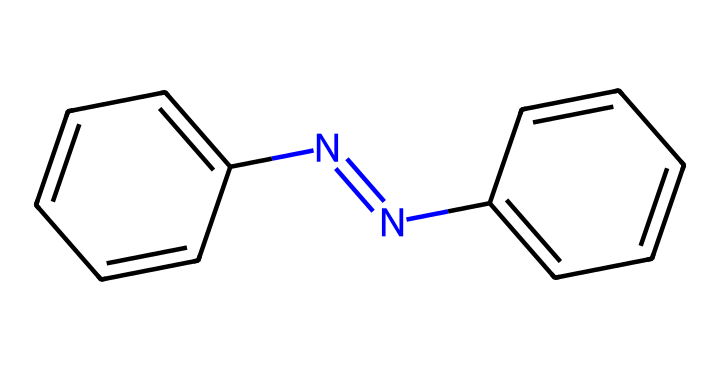What is the name of this chemical? The chemical structure represents azobenzene, which is characterized by the azo group (N=N) linking two phenyl rings.
Answer: azobenzene How many nitrogen atoms are present in this molecule? In the provided SMILES representation, there are two nitrogen atoms connected by a double bond (N=N).
Answer: two What is the overall molecular symmetry of azobenzene? Azobenzene exhibits planar molecular symmetry due to the arrangement of the two phenyl rings around the central azo group.
Answer: planar Which functional group is responsible for the photoswitchable properties of this molecule? The azo group (N=N) is responsible for the photoswitchable properties, allowing azobenzene to change its configuration upon light exposure.
Answer: azo group What is the effect of light on the configuration of azobenzene? Light causes azobenzene to undergo isomerization, specifically switching between the trans and cis configurations, changing its physical properties.
Answer: isomerization How many phenyl rings are in azobenzene? There are two phenyl rings attached to either side of the azo group in the azobenzene structure.
Answer: two What color does the azobenzene absorb in the UV-Vis spectrum? Azobenzene typically absorbs light in the UV region, often around 350 nm, which can lead to its colorless appearance in solution.
Answer: UV region 